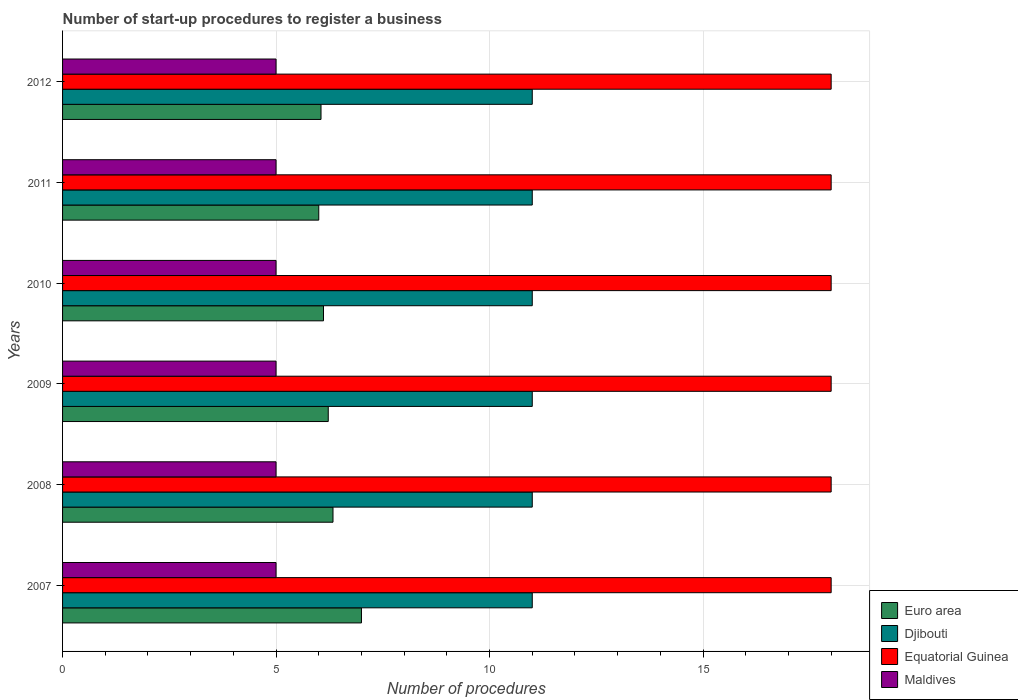How many different coloured bars are there?
Offer a terse response. 4. How many groups of bars are there?
Provide a succinct answer. 6. Are the number of bars on each tick of the Y-axis equal?
Offer a very short reply. Yes. How many bars are there on the 5th tick from the top?
Make the answer very short. 4. How many bars are there on the 5th tick from the bottom?
Give a very brief answer. 4. What is the number of procedures required to register a business in Euro area in 2008?
Keep it short and to the point. 6.33. Across all years, what is the minimum number of procedures required to register a business in Euro area?
Keep it short and to the point. 6. What is the difference between the number of procedures required to register a business in Equatorial Guinea in 2011 and the number of procedures required to register a business in Maldives in 2012?
Your answer should be compact. 13. What is the average number of procedures required to register a business in Euro area per year?
Provide a succinct answer. 6.29. In the year 2012, what is the difference between the number of procedures required to register a business in Equatorial Guinea and number of procedures required to register a business in Maldives?
Offer a very short reply. 13. Is the number of procedures required to register a business in Djibouti in 2008 less than that in 2011?
Give a very brief answer. No. Is the difference between the number of procedures required to register a business in Equatorial Guinea in 2011 and 2012 greater than the difference between the number of procedures required to register a business in Maldives in 2011 and 2012?
Your answer should be compact. No. What is the difference between the highest and the second highest number of procedures required to register a business in Euro area?
Make the answer very short. 0.67. In how many years, is the number of procedures required to register a business in Maldives greater than the average number of procedures required to register a business in Maldives taken over all years?
Ensure brevity in your answer.  0. Is it the case that in every year, the sum of the number of procedures required to register a business in Djibouti and number of procedures required to register a business in Maldives is greater than the sum of number of procedures required to register a business in Equatorial Guinea and number of procedures required to register a business in Euro area?
Make the answer very short. Yes. What does the 3rd bar from the top in 2012 represents?
Make the answer very short. Djibouti. Are all the bars in the graph horizontal?
Give a very brief answer. Yes. How are the legend labels stacked?
Keep it short and to the point. Vertical. What is the title of the graph?
Your response must be concise. Number of start-up procedures to register a business. What is the label or title of the X-axis?
Give a very brief answer. Number of procedures. What is the label or title of the Y-axis?
Keep it short and to the point. Years. What is the Number of procedures of Euro area in 2007?
Your answer should be very brief. 7. What is the Number of procedures in Djibouti in 2007?
Your answer should be very brief. 11. What is the Number of procedures of Maldives in 2007?
Keep it short and to the point. 5. What is the Number of procedures in Euro area in 2008?
Keep it short and to the point. 6.33. What is the Number of procedures of Euro area in 2009?
Your response must be concise. 6.22. What is the Number of procedures in Maldives in 2009?
Offer a very short reply. 5. What is the Number of procedures of Euro area in 2010?
Provide a succinct answer. 6.11. What is the Number of procedures in Djibouti in 2010?
Keep it short and to the point. 11. What is the Number of procedures in Equatorial Guinea in 2011?
Offer a very short reply. 18. What is the Number of procedures in Maldives in 2011?
Your answer should be very brief. 5. What is the Number of procedures of Euro area in 2012?
Your answer should be very brief. 6.05. What is the Number of procedures in Maldives in 2012?
Ensure brevity in your answer.  5. Across all years, what is the maximum Number of procedures of Djibouti?
Ensure brevity in your answer.  11. Across all years, what is the minimum Number of procedures in Djibouti?
Make the answer very short. 11. Across all years, what is the minimum Number of procedures of Equatorial Guinea?
Provide a short and direct response. 18. What is the total Number of procedures in Euro area in the graph?
Your response must be concise. 37.72. What is the total Number of procedures in Equatorial Guinea in the graph?
Your answer should be compact. 108. What is the total Number of procedures in Maldives in the graph?
Offer a very short reply. 30. What is the difference between the Number of procedures in Djibouti in 2007 and that in 2008?
Offer a very short reply. 0. What is the difference between the Number of procedures in Euro area in 2007 and that in 2009?
Give a very brief answer. 0.78. What is the difference between the Number of procedures in Djibouti in 2007 and that in 2009?
Your response must be concise. 0. What is the difference between the Number of procedures in Euro area in 2007 and that in 2010?
Offer a very short reply. 0.89. What is the difference between the Number of procedures of Djibouti in 2007 and that in 2010?
Your response must be concise. 0. What is the difference between the Number of procedures of Djibouti in 2007 and that in 2011?
Offer a very short reply. 0. What is the difference between the Number of procedures in Maldives in 2007 and that in 2011?
Provide a short and direct response. 0. What is the difference between the Number of procedures in Euro area in 2007 and that in 2012?
Offer a very short reply. 0.95. What is the difference between the Number of procedures in Maldives in 2007 and that in 2012?
Keep it short and to the point. 0. What is the difference between the Number of procedures in Maldives in 2008 and that in 2009?
Keep it short and to the point. 0. What is the difference between the Number of procedures of Euro area in 2008 and that in 2010?
Make the answer very short. 0.22. What is the difference between the Number of procedures in Maldives in 2008 and that in 2010?
Give a very brief answer. 0. What is the difference between the Number of procedures of Euro area in 2008 and that in 2011?
Ensure brevity in your answer.  0.33. What is the difference between the Number of procedures in Equatorial Guinea in 2008 and that in 2011?
Provide a succinct answer. 0. What is the difference between the Number of procedures in Maldives in 2008 and that in 2011?
Give a very brief answer. 0. What is the difference between the Number of procedures of Euro area in 2008 and that in 2012?
Offer a very short reply. 0.28. What is the difference between the Number of procedures of Maldives in 2008 and that in 2012?
Make the answer very short. 0. What is the difference between the Number of procedures of Euro area in 2009 and that in 2010?
Your answer should be compact. 0.11. What is the difference between the Number of procedures of Djibouti in 2009 and that in 2010?
Offer a terse response. 0. What is the difference between the Number of procedures of Equatorial Guinea in 2009 and that in 2010?
Make the answer very short. 0. What is the difference between the Number of procedures of Euro area in 2009 and that in 2011?
Provide a succinct answer. 0.22. What is the difference between the Number of procedures in Maldives in 2009 and that in 2011?
Your answer should be very brief. 0. What is the difference between the Number of procedures in Euro area in 2009 and that in 2012?
Give a very brief answer. 0.17. What is the difference between the Number of procedures of Djibouti in 2009 and that in 2012?
Make the answer very short. 0. What is the difference between the Number of procedures of Maldives in 2009 and that in 2012?
Offer a terse response. 0. What is the difference between the Number of procedures of Djibouti in 2010 and that in 2011?
Make the answer very short. 0. What is the difference between the Number of procedures in Equatorial Guinea in 2010 and that in 2011?
Make the answer very short. 0. What is the difference between the Number of procedures in Maldives in 2010 and that in 2011?
Offer a terse response. 0. What is the difference between the Number of procedures of Euro area in 2010 and that in 2012?
Make the answer very short. 0.06. What is the difference between the Number of procedures of Equatorial Guinea in 2010 and that in 2012?
Ensure brevity in your answer.  0. What is the difference between the Number of procedures of Euro area in 2011 and that in 2012?
Keep it short and to the point. -0.05. What is the difference between the Number of procedures of Djibouti in 2011 and that in 2012?
Offer a very short reply. 0. What is the difference between the Number of procedures in Equatorial Guinea in 2011 and that in 2012?
Give a very brief answer. 0. What is the difference between the Number of procedures in Euro area in 2007 and the Number of procedures in Equatorial Guinea in 2008?
Offer a very short reply. -11. What is the difference between the Number of procedures in Djibouti in 2007 and the Number of procedures in Equatorial Guinea in 2008?
Ensure brevity in your answer.  -7. What is the difference between the Number of procedures of Euro area in 2007 and the Number of procedures of Djibouti in 2009?
Ensure brevity in your answer.  -4. What is the difference between the Number of procedures of Djibouti in 2007 and the Number of procedures of Equatorial Guinea in 2009?
Keep it short and to the point. -7. What is the difference between the Number of procedures in Djibouti in 2007 and the Number of procedures in Maldives in 2009?
Provide a succinct answer. 6. What is the difference between the Number of procedures in Equatorial Guinea in 2007 and the Number of procedures in Maldives in 2009?
Provide a short and direct response. 13. What is the difference between the Number of procedures in Euro area in 2007 and the Number of procedures in Maldives in 2010?
Keep it short and to the point. 2. What is the difference between the Number of procedures in Djibouti in 2007 and the Number of procedures in Equatorial Guinea in 2010?
Offer a terse response. -7. What is the difference between the Number of procedures in Equatorial Guinea in 2007 and the Number of procedures in Maldives in 2010?
Keep it short and to the point. 13. What is the difference between the Number of procedures of Djibouti in 2007 and the Number of procedures of Maldives in 2011?
Give a very brief answer. 6. What is the difference between the Number of procedures in Euro area in 2007 and the Number of procedures in Equatorial Guinea in 2012?
Make the answer very short. -11. What is the difference between the Number of procedures of Djibouti in 2007 and the Number of procedures of Maldives in 2012?
Offer a terse response. 6. What is the difference between the Number of procedures in Euro area in 2008 and the Number of procedures in Djibouti in 2009?
Provide a short and direct response. -4.67. What is the difference between the Number of procedures in Euro area in 2008 and the Number of procedures in Equatorial Guinea in 2009?
Ensure brevity in your answer.  -11.67. What is the difference between the Number of procedures of Euro area in 2008 and the Number of procedures of Maldives in 2009?
Give a very brief answer. 1.33. What is the difference between the Number of procedures of Euro area in 2008 and the Number of procedures of Djibouti in 2010?
Your answer should be very brief. -4.67. What is the difference between the Number of procedures of Euro area in 2008 and the Number of procedures of Equatorial Guinea in 2010?
Make the answer very short. -11.67. What is the difference between the Number of procedures of Euro area in 2008 and the Number of procedures of Maldives in 2010?
Your answer should be compact. 1.33. What is the difference between the Number of procedures in Djibouti in 2008 and the Number of procedures in Equatorial Guinea in 2010?
Provide a short and direct response. -7. What is the difference between the Number of procedures of Djibouti in 2008 and the Number of procedures of Maldives in 2010?
Provide a succinct answer. 6. What is the difference between the Number of procedures of Euro area in 2008 and the Number of procedures of Djibouti in 2011?
Provide a succinct answer. -4.67. What is the difference between the Number of procedures in Euro area in 2008 and the Number of procedures in Equatorial Guinea in 2011?
Make the answer very short. -11.67. What is the difference between the Number of procedures of Euro area in 2008 and the Number of procedures of Maldives in 2011?
Your answer should be very brief. 1.33. What is the difference between the Number of procedures in Djibouti in 2008 and the Number of procedures in Equatorial Guinea in 2011?
Provide a short and direct response. -7. What is the difference between the Number of procedures of Equatorial Guinea in 2008 and the Number of procedures of Maldives in 2011?
Keep it short and to the point. 13. What is the difference between the Number of procedures of Euro area in 2008 and the Number of procedures of Djibouti in 2012?
Offer a terse response. -4.67. What is the difference between the Number of procedures of Euro area in 2008 and the Number of procedures of Equatorial Guinea in 2012?
Offer a terse response. -11.67. What is the difference between the Number of procedures in Euro area in 2008 and the Number of procedures in Maldives in 2012?
Offer a terse response. 1.33. What is the difference between the Number of procedures in Euro area in 2009 and the Number of procedures in Djibouti in 2010?
Offer a terse response. -4.78. What is the difference between the Number of procedures in Euro area in 2009 and the Number of procedures in Equatorial Guinea in 2010?
Your answer should be compact. -11.78. What is the difference between the Number of procedures in Euro area in 2009 and the Number of procedures in Maldives in 2010?
Make the answer very short. 1.22. What is the difference between the Number of procedures in Djibouti in 2009 and the Number of procedures in Maldives in 2010?
Offer a very short reply. 6. What is the difference between the Number of procedures in Equatorial Guinea in 2009 and the Number of procedures in Maldives in 2010?
Offer a terse response. 13. What is the difference between the Number of procedures in Euro area in 2009 and the Number of procedures in Djibouti in 2011?
Offer a terse response. -4.78. What is the difference between the Number of procedures of Euro area in 2009 and the Number of procedures of Equatorial Guinea in 2011?
Provide a succinct answer. -11.78. What is the difference between the Number of procedures in Euro area in 2009 and the Number of procedures in Maldives in 2011?
Make the answer very short. 1.22. What is the difference between the Number of procedures of Djibouti in 2009 and the Number of procedures of Equatorial Guinea in 2011?
Your answer should be very brief. -7. What is the difference between the Number of procedures of Equatorial Guinea in 2009 and the Number of procedures of Maldives in 2011?
Provide a short and direct response. 13. What is the difference between the Number of procedures in Euro area in 2009 and the Number of procedures in Djibouti in 2012?
Offer a very short reply. -4.78. What is the difference between the Number of procedures of Euro area in 2009 and the Number of procedures of Equatorial Guinea in 2012?
Your answer should be very brief. -11.78. What is the difference between the Number of procedures of Euro area in 2009 and the Number of procedures of Maldives in 2012?
Your response must be concise. 1.22. What is the difference between the Number of procedures in Djibouti in 2009 and the Number of procedures in Maldives in 2012?
Your answer should be compact. 6. What is the difference between the Number of procedures of Euro area in 2010 and the Number of procedures of Djibouti in 2011?
Offer a very short reply. -4.89. What is the difference between the Number of procedures of Euro area in 2010 and the Number of procedures of Equatorial Guinea in 2011?
Provide a short and direct response. -11.89. What is the difference between the Number of procedures in Djibouti in 2010 and the Number of procedures in Maldives in 2011?
Your answer should be compact. 6. What is the difference between the Number of procedures of Euro area in 2010 and the Number of procedures of Djibouti in 2012?
Provide a succinct answer. -4.89. What is the difference between the Number of procedures of Euro area in 2010 and the Number of procedures of Equatorial Guinea in 2012?
Provide a short and direct response. -11.89. What is the difference between the Number of procedures in Equatorial Guinea in 2010 and the Number of procedures in Maldives in 2012?
Your answer should be compact. 13. What is the difference between the Number of procedures of Euro area in 2011 and the Number of procedures of Djibouti in 2012?
Make the answer very short. -5. What is the difference between the Number of procedures in Euro area in 2011 and the Number of procedures in Equatorial Guinea in 2012?
Your response must be concise. -12. What is the difference between the Number of procedures of Euro area in 2011 and the Number of procedures of Maldives in 2012?
Your answer should be very brief. 1. What is the average Number of procedures of Euro area per year?
Offer a terse response. 6.29. What is the average Number of procedures in Equatorial Guinea per year?
Keep it short and to the point. 18. What is the average Number of procedures of Maldives per year?
Keep it short and to the point. 5. In the year 2007, what is the difference between the Number of procedures of Djibouti and Number of procedures of Maldives?
Ensure brevity in your answer.  6. In the year 2008, what is the difference between the Number of procedures in Euro area and Number of procedures in Djibouti?
Give a very brief answer. -4.67. In the year 2008, what is the difference between the Number of procedures of Euro area and Number of procedures of Equatorial Guinea?
Provide a succinct answer. -11.67. In the year 2008, what is the difference between the Number of procedures in Euro area and Number of procedures in Maldives?
Give a very brief answer. 1.33. In the year 2008, what is the difference between the Number of procedures in Djibouti and Number of procedures in Equatorial Guinea?
Make the answer very short. -7. In the year 2008, what is the difference between the Number of procedures in Equatorial Guinea and Number of procedures in Maldives?
Keep it short and to the point. 13. In the year 2009, what is the difference between the Number of procedures in Euro area and Number of procedures in Djibouti?
Ensure brevity in your answer.  -4.78. In the year 2009, what is the difference between the Number of procedures in Euro area and Number of procedures in Equatorial Guinea?
Give a very brief answer. -11.78. In the year 2009, what is the difference between the Number of procedures in Euro area and Number of procedures in Maldives?
Offer a very short reply. 1.22. In the year 2009, what is the difference between the Number of procedures of Equatorial Guinea and Number of procedures of Maldives?
Make the answer very short. 13. In the year 2010, what is the difference between the Number of procedures of Euro area and Number of procedures of Djibouti?
Offer a very short reply. -4.89. In the year 2010, what is the difference between the Number of procedures of Euro area and Number of procedures of Equatorial Guinea?
Offer a very short reply. -11.89. In the year 2010, what is the difference between the Number of procedures in Euro area and Number of procedures in Maldives?
Your answer should be very brief. 1.11. In the year 2010, what is the difference between the Number of procedures of Djibouti and Number of procedures of Equatorial Guinea?
Your answer should be very brief. -7. In the year 2010, what is the difference between the Number of procedures in Djibouti and Number of procedures in Maldives?
Provide a short and direct response. 6. In the year 2010, what is the difference between the Number of procedures of Equatorial Guinea and Number of procedures of Maldives?
Keep it short and to the point. 13. In the year 2011, what is the difference between the Number of procedures in Djibouti and Number of procedures in Equatorial Guinea?
Provide a short and direct response. -7. In the year 2011, what is the difference between the Number of procedures in Equatorial Guinea and Number of procedures in Maldives?
Your answer should be very brief. 13. In the year 2012, what is the difference between the Number of procedures in Euro area and Number of procedures in Djibouti?
Ensure brevity in your answer.  -4.95. In the year 2012, what is the difference between the Number of procedures of Euro area and Number of procedures of Equatorial Guinea?
Ensure brevity in your answer.  -11.95. In the year 2012, what is the difference between the Number of procedures in Euro area and Number of procedures in Maldives?
Offer a terse response. 1.05. In the year 2012, what is the difference between the Number of procedures in Djibouti and Number of procedures in Equatorial Guinea?
Ensure brevity in your answer.  -7. In the year 2012, what is the difference between the Number of procedures of Djibouti and Number of procedures of Maldives?
Your response must be concise. 6. In the year 2012, what is the difference between the Number of procedures of Equatorial Guinea and Number of procedures of Maldives?
Offer a terse response. 13. What is the ratio of the Number of procedures of Euro area in 2007 to that in 2008?
Your response must be concise. 1.11. What is the ratio of the Number of procedures of Equatorial Guinea in 2007 to that in 2008?
Make the answer very short. 1. What is the ratio of the Number of procedures of Euro area in 2007 to that in 2009?
Keep it short and to the point. 1.12. What is the ratio of the Number of procedures of Maldives in 2007 to that in 2009?
Your answer should be very brief. 1. What is the ratio of the Number of procedures in Euro area in 2007 to that in 2010?
Your response must be concise. 1.15. What is the ratio of the Number of procedures in Equatorial Guinea in 2007 to that in 2010?
Keep it short and to the point. 1. What is the ratio of the Number of procedures in Maldives in 2007 to that in 2010?
Offer a terse response. 1. What is the ratio of the Number of procedures of Equatorial Guinea in 2007 to that in 2011?
Ensure brevity in your answer.  1. What is the ratio of the Number of procedures in Euro area in 2007 to that in 2012?
Make the answer very short. 1.16. What is the ratio of the Number of procedures of Maldives in 2007 to that in 2012?
Your answer should be compact. 1. What is the ratio of the Number of procedures in Euro area in 2008 to that in 2009?
Provide a short and direct response. 1.02. What is the ratio of the Number of procedures of Equatorial Guinea in 2008 to that in 2009?
Offer a very short reply. 1. What is the ratio of the Number of procedures of Maldives in 2008 to that in 2009?
Give a very brief answer. 1. What is the ratio of the Number of procedures in Euro area in 2008 to that in 2010?
Your answer should be very brief. 1.04. What is the ratio of the Number of procedures in Djibouti in 2008 to that in 2010?
Your answer should be very brief. 1. What is the ratio of the Number of procedures of Maldives in 2008 to that in 2010?
Offer a very short reply. 1. What is the ratio of the Number of procedures in Euro area in 2008 to that in 2011?
Offer a very short reply. 1.06. What is the ratio of the Number of procedures of Djibouti in 2008 to that in 2011?
Offer a very short reply. 1. What is the ratio of the Number of procedures in Euro area in 2008 to that in 2012?
Your answer should be compact. 1.05. What is the ratio of the Number of procedures in Equatorial Guinea in 2008 to that in 2012?
Provide a short and direct response. 1. What is the ratio of the Number of procedures of Euro area in 2009 to that in 2010?
Offer a very short reply. 1.02. What is the ratio of the Number of procedures of Equatorial Guinea in 2009 to that in 2010?
Your response must be concise. 1. What is the ratio of the Number of procedures of Djibouti in 2009 to that in 2011?
Your response must be concise. 1. What is the ratio of the Number of procedures in Maldives in 2009 to that in 2011?
Give a very brief answer. 1. What is the ratio of the Number of procedures in Euro area in 2009 to that in 2012?
Offer a terse response. 1.03. What is the ratio of the Number of procedures of Djibouti in 2009 to that in 2012?
Give a very brief answer. 1. What is the ratio of the Number of procedures of Euro area in 2010 to that in 2011?
Your response must be concise. 1.02. What is the ratio of the Number of procedures in Djibouti in 2010 to that in 2011?
Keep it short and to the point. 1. What is the ratio of the Number of procedures in Equatorial Guinea in 2010 to that in 2011?
Provide a short and direct response. 1. What is the ratio of the Number of procedures of Euro area in 2010 to that in 2012?
Keep it short and to the point. 1.01. What is the ratio of the Number of procedures of Equatorial Guinea in 2010 to that in 2012?
Keep it short and to the point. 1. What is the ratio of the Number of procedures in Equatorial Guinea in 2011 to that in 2012?
Provide a short and direct response. 1. What is the ratio of the Number of procedures in Maldives in 2011 to that in 2012?
Provide a short and direct response. 1. What is the difference between the highest and the second highest Number of procedures in Djibouti?
Your response must be concise. 0. What is the difference between the highest and the second highest Number of procedures of Maldives?
Provide a short and direct response. 0. What is the difference between the highest and the lowest Number of procedures of Euro area?
Your response must be concise. 1. 